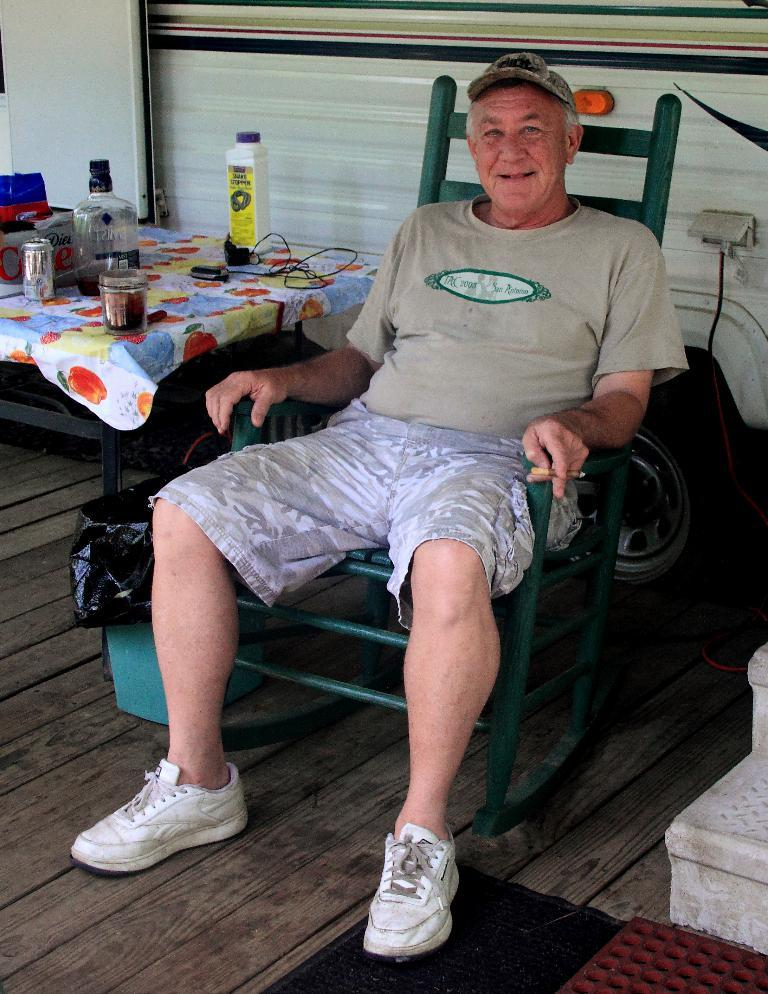What is the man in the image doing? The man is sitting on a chair in the image. What object is located behind the man? There is a dustbin behind the man. What piece of furniture is present in the image? There is a table in the image. What items can be seen on the table? There are bottles on the table. Can you tell me how many donkeys are present in the image? There are no donkeys present in the image. What type of metal is the table made of in the image? The type of metal the table is made of is not mentioned in the image. 